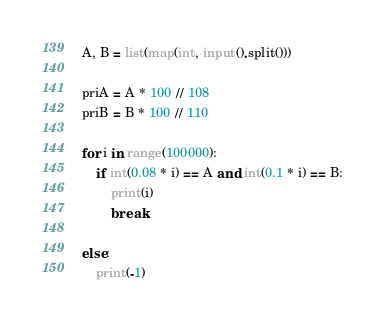<code> <loc_0><loc_0><loc_500><loc_500><_Python_>A, B = list(map(int, input().split()))

priA = A * 100 // 108
priB = B * 100 // 110

for i in range(100000):
    if int(0.08 * i) == A and int(0.1 * i) == B:
        print(i)
        break

else:
    print(-1)</code> 